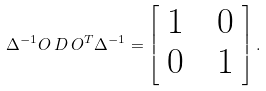Convert formula to latex. <formula><loc_0><loc_0><loc_500><loc_500>\Delta ^ { - 1 } O \, { D } \, O ^ { T } \Delta ^ { - 1 } = \left [ \begin{array} { c c c } 1 & & 0 \\ 0 & & 1 \end{array} \right ] .</formula> 